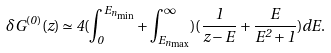<formula> <loc_0><loc_0><loc_500><loc_500>\delta G ^ { ( 0 ) } ( z ) \simeq 4 ( \int _ { 0 } ^ { E _ { n _ { \min } } } + \int _ { E _ { n _ { \max } } } ^ { \infty } ) ( \frac { 1 } { z - E } + \frac { E } { E ^ { 2 } + 1 } ) d E .</formula> 